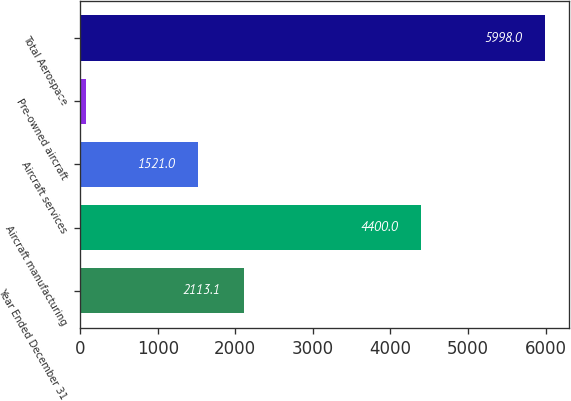<chart> <loc_0><loc_0><loc_500><loc_500><bar_chart><fcel>Year Ended December 31<fcel>Aircraft manufacturing<fcel>Aircraft services<fcel>Pre-owned aircraft<fcel>Total Aerospace<nl><fcel>2113.1<fcel>4400<fcel>1521<fcel>77<fcel>5998<nl></chart> 